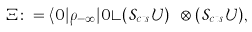Convert formula to latex. <formula><loc_0><loc_0><loc_500><loc_500>\Xi \colon = \langle 0 | \rho _ { - \infty } | 0 \rangle ( { \mathcal { S } } _ { c t s } { \mathcal { U } } ) ^ { \dagger } \otimes ( { \mathcal { S } } _ { c t s } { \mathcal { U } } ) ,</formula> 